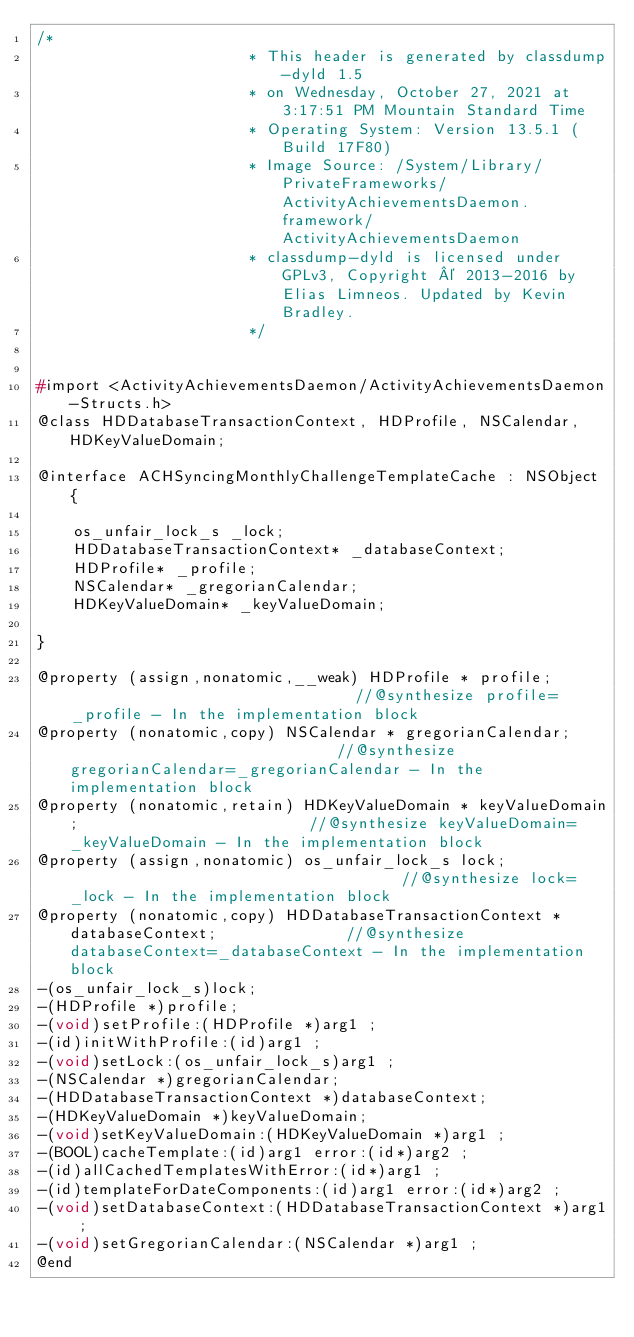Convert code to text. <code><loc_0><loc_0><loc_500><loc_500><_C_>/*
                       * This header is generated by classdump-dyld 1.5
                       * on Wednesday, October 27, 2021 at 3:17:51 PM Mountain Standard Time
                       * Operating System: Version 13.5.1 (Build 17F80)
                       * Image Source: /System/Library/PrivateFrameworks/ActivityAchievementsDaemon.framework/ActivityAchievementsDaemon
                       * classdump-dyld is licensed under GPLv3, Copyright © 2013-2016 by Elias Limneos. Updated by Kevin Bradley.
                       */


#import <ActivityAchievementsDaemon/ActivityAchievementsDaemon-Structs.h>
@class HDDatabaseTransactionContext, HDProfile, NSCalendar, HDKeyValueDomain;

@interface ACHSyncingMonthlyChallengeTemplateCache : NSObject {

	os_unfair_lock_s _lock;
	HDDatabaseTransactionContext* _databaseContext;
	HDProfile* _profile;
	NSCalendar* _gregorianCalendar;
	HDKeyValueDomain* _keyValueDomain;

}

@property (assign,nonatomic,__weak) HDProfile * profile;                                //@synthesize profile=_profile - In the implementation block
@property (nonatomic,copy) NSCalendar * gregorianCalendar;                              //@synthesize gregorianCalendar=_gregorianCalendar - In the implementation block
@property (nonatomic,retain) HDKeyValueDomain * keyValueDomain;                         //@synthesize keyValueDomain=_keyValueDomain - In the implementation block
@property (assign,nonatomic) os_unfair_lock_s lock;                                     //@synthesize lock=_lock - In the implementation block
@property (nonatomic,copy) HDDatabaseTransactionContext * databaseContext;              //@synthesize databaseContext=_databaseContext - In the implementation block
-(os_unfair_lock_s)lock;
-(HDProfile *)profile;
-(void)setProfile:(HDProfile *)arg1 ;
-(id)initWithProfile:(id)arg1 ;
-(void)setLock:(os_unfair_lock_s)arg1 ;
-(NSCalendar *)gregorianCalendar;
-(HDDatabaseTransactionContext *)databaseContext;
-(HDKeyValueDomain *)keyValueDomain;
-(void)setKeyValueDomain:(HDKeyValueDomain *)arg1 ;
-(BOOL)cacheTemplate:(id)arg1 error:(id*)arg2 ;
-(id)allCachedTemplatesWithError:(id*)arg1 ;
-(id)templateForDateComponents:(id)arg1 error:(id*)arg2 ;
-(void)setDatabaseContext:(HDDatabaseTransactionContext *)arg1 ;
-(void)setGregorianCalendar:(NSCalendar *)arg1 ;
@end

</code> 